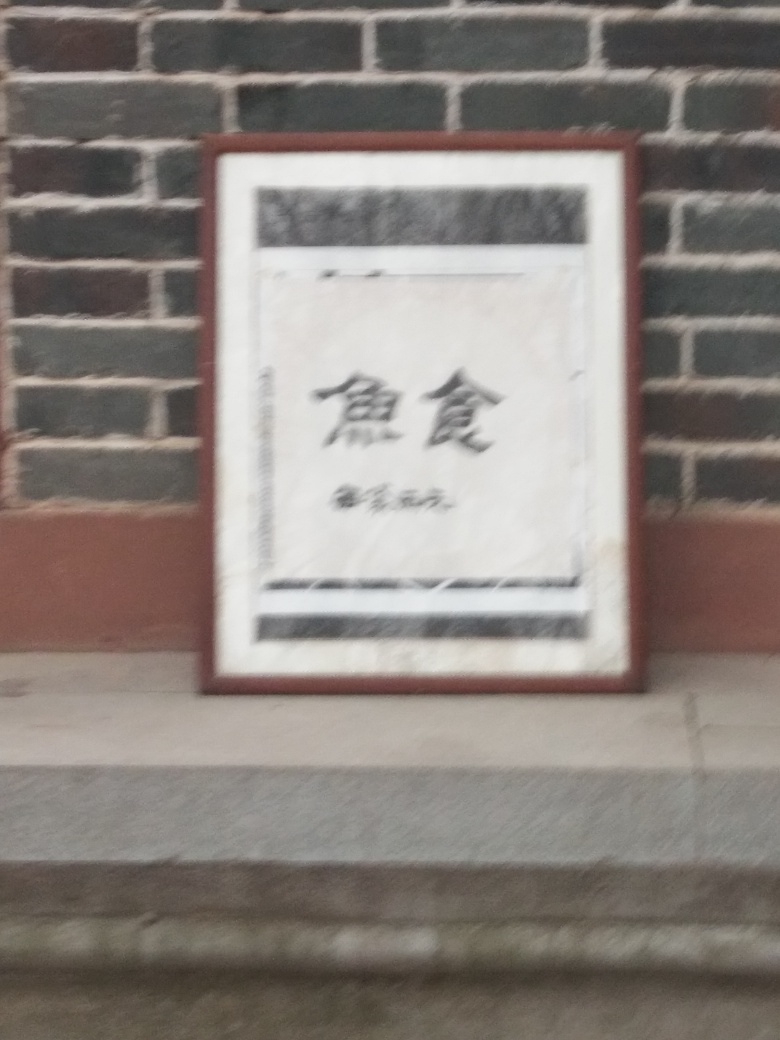Can you tell what is written on the sign? Unfortunately, I cannot provide details about the text because the image is blurry. However, it looks like a framed sign which could contain informative content, possibly with artistic or decorative calligraphy. 